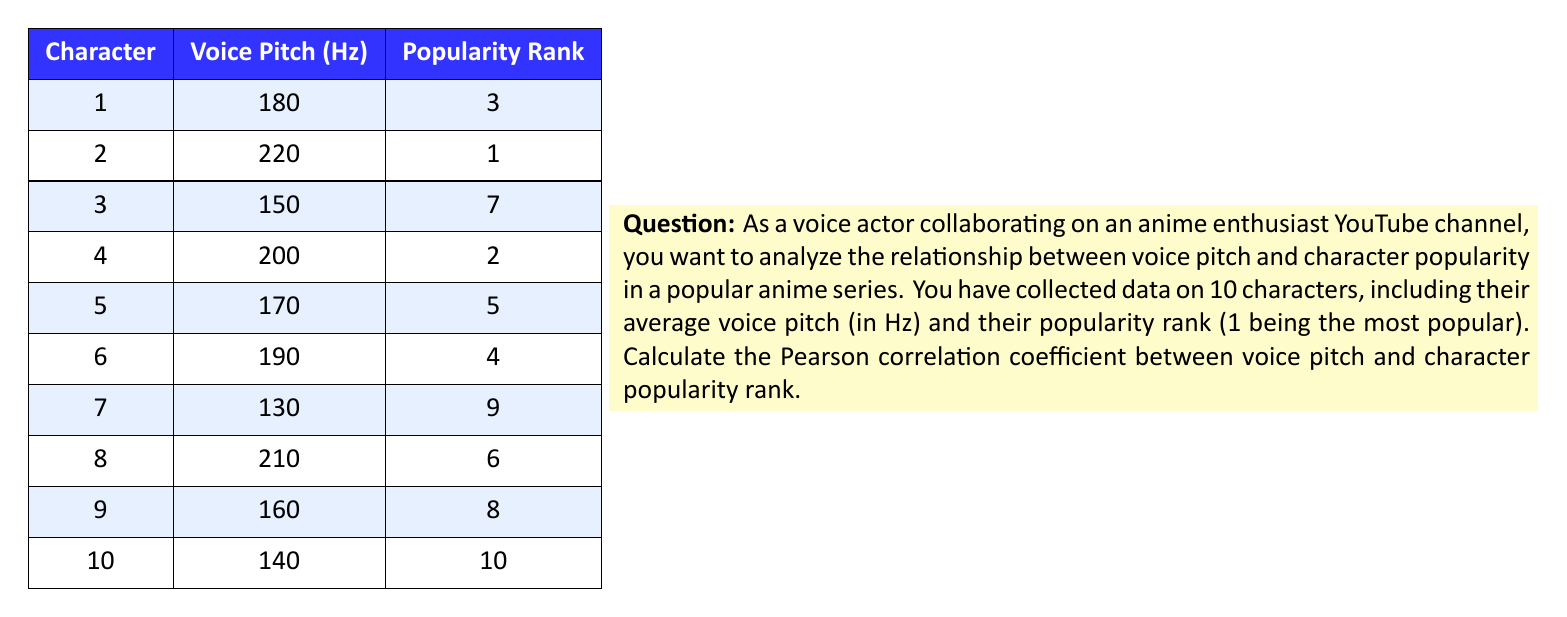Give your solution to this math problem. To calculate the Pearson correlation coefficient $(r)$ between voice pitch $(X)$ and popularity rank $(Y)$, we'll use the formula:

$$ r = \frac{n\sum xy - (\sum x)(\sum y)}{\sqrt{[n\sum x^2 - (\sum x)^2][n\sum y^2 - (\sum y)^2]}} $$

Where $n$ is the number of data points.

Step 1: Calculate the necessary sums:
$n = 10$
$\sum x = 1750$ (sum of voice pitches)
$\sum y = 55$ (sum of popularity ranks)
$\sum xy = 9660$ (sum of products)
$\sum x^2 = 315,700$ (sum of squared voice pitches)
$\sum y^2 = 385$ (sum of squared popularity ranks)

Step 2: Substitute these values into the formula:

$$ r = \frac{10(9660) - (1750)(55)}{\sqrt{[10(315,700) - 1750^2][10(385) - 55^2]}} $$

Step 3: Simplify:

$$ r = \frac{96,600 - 96,250}{\sqrt{(3,157,000 - 3,062,500)(3,850 - 3,025)}} $$

$$ r = \frac{350}{\sqrt{(94,500)(825)}} $$

$$ r = \frac{350}{\sqrt{77,962,500}} $$

$$ r = \frac{350}{8,830.20} $$

Step 4: Calculate the final result:

$$ r \approx -0.0396 $$
Answer: $r \approx -0.0396$ 